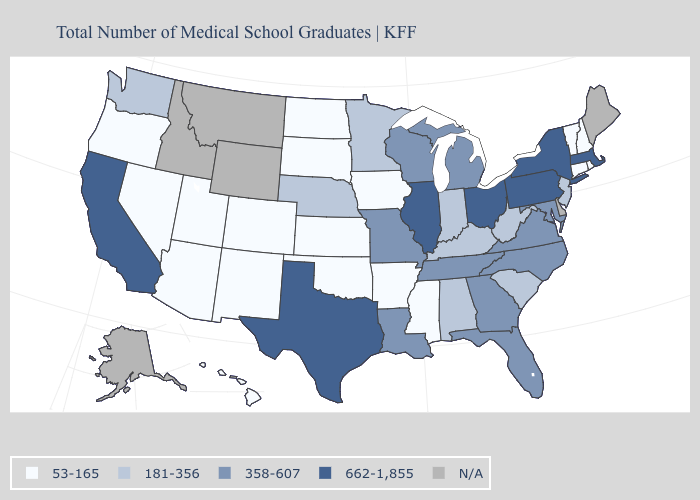What is the value of Arizona?
Be succinct. 53-165. Name the states that have a value in the range 53-165?
Short answer required. Arizona, Arkansas, Colorado, Connecticut, Hawaii, Iowa, Kansas, Mississippi, Nevada, New Hampshire, New Mexico, North Dakota, Oklahoma, Oregon, Rhode Island, South Dakota, Utah, Vermont. Name the states that have a value in the range 53-165?
Keep it brief. Arizona, Arkansas, Colorado, Connecticut, Hawaii, Iowa, Kansas, Mississippi, Nevada, New Hampshire, New Mexico, North Dakota, Oklahoma, Oregon, Rhode Island, South Dakota, Utah, Vermont. What is the value of Texas?
Keep it brief. 662-1,855. What is the lowest value in states that border Indiana?
Give a very brief answer. 181-356. Name the states that have a value in the range 181-356?
Keep it brief. Alabama, Indiana, Kentucky, Minnesota, Nebraska, New Jersey, South Carolina, Washington, West Virginia. Name the states that have a value in the range 662-1,855?
Keep it brief. California, Illinois, Massachusetts, New York, Ohio, Pennsylvania, Texas. What is the lowest value in states that border Alabama?
Short answer required. 53-165. Name the states that have a value in the range 662-1,855?
Give a very brief answer. California, Illinois, Massachusetts, New York, Ohio, Pennsylvania, Texas. Which states hav the highest value in the South?
Quick response, please. Texas. What is the lowest value in states that border Oregon?
Be succinct. 53-165. Does California have the highest value in the West?
Answer briefly. Yes. Which states have the highest value in the USA?
Concise answer only. California, Illinois, Massachusetts, New York, Ohio, Pennsylvania, Texas. What is the value of Idaho?
Concise answer only. N/A. What is the value of Louisiana?
Answer briefly. 358-607. 